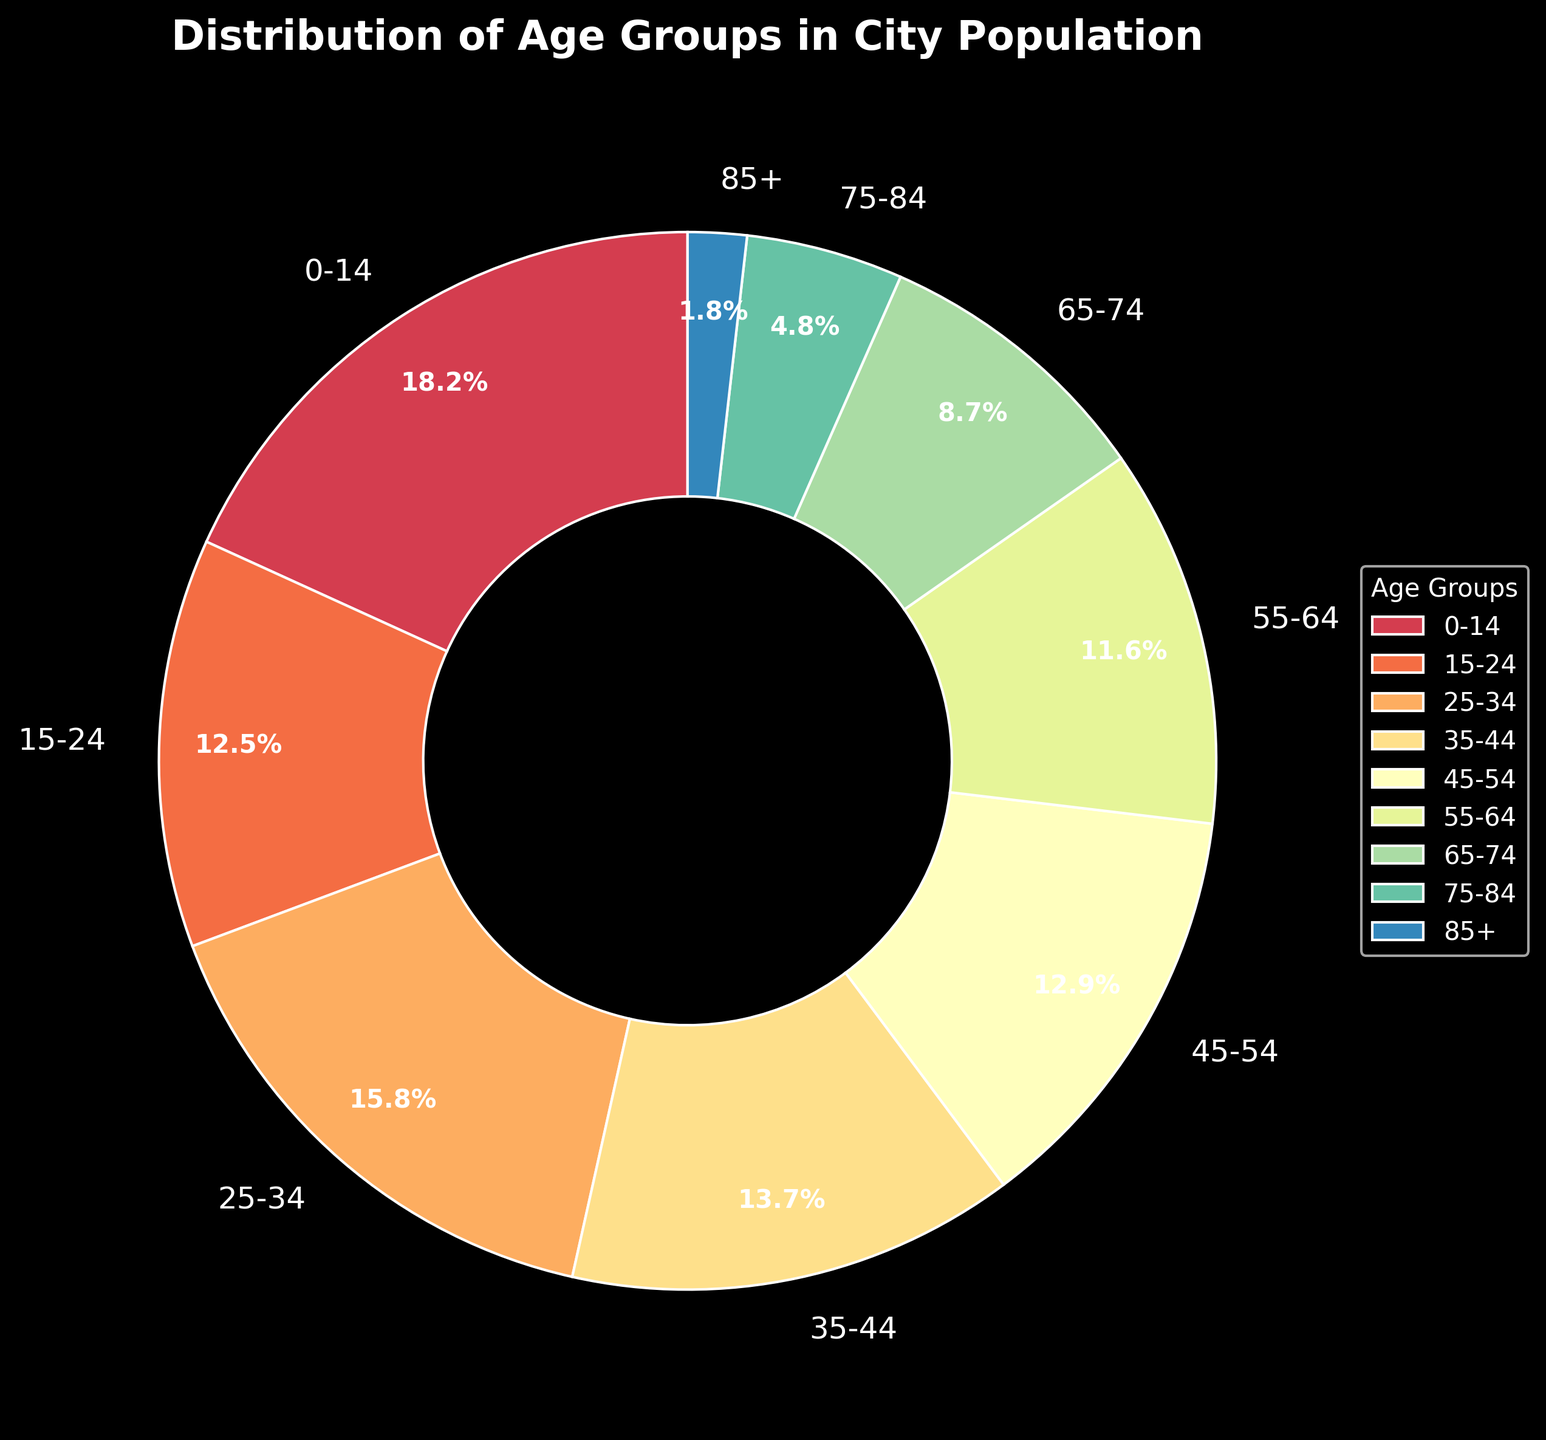Which age group has the highest population percentage? The pie chart shows that the '0-14' age group has the highest percentage.
Answer: 0-14 Which age group has the lowest population percentage? The '85+' age group has the smallest slice in the pie chart.
Answer: 85+ How much larger is the population percentage of the '25-34' age group compared to the '75-84' age group? The '25-34' age group has 15.8%, and the '75-84' age group has 4.8%. The difference is 15.8% - 4.8% = 11%.
Answer: 11% What is the total population percentage of the age groups 0-14, 15-24, and 25-34 combined? Add the percentages of the '0-14' (18.2%), '15-24' (12.5%), and '25-34' (15.8%) age groups: 18.2% + 12.5% + 15.8% = 46.5%.
Answer: 46.5% Does the '55-64' age group have a higher population percentage than the '65-74' age group? The '55-64' age group has a percentage of 11.6%, while the '65-74' age group has 8.7%. Since 11.6% is greater than 8.7%, '55-64' has a higher percentage.
Answer: Yes What is the difference between the population percentages of the '35-44' and '45-54' age groups? The '35-44' age group has 13.7%, and the '45-54' age group has 12.9%. The difference is 13.7% - 12.9% = 0.8%.
Answer: 0.8% What is the average population percentage for all age groups? Sum all the percentages and divide by the number of age groups: (18.2 + 12.5 + 15.8 + 13.7 + 12.9 + 11.6 + 8.7 + 4.8 + 1.8) / 9 = 11.1%.
Answer: 11.1% Which three age groups have the smallest population percentages, and what is their combined percentage? The smallest percentages are for the '85+' (1.8%), '75-84' (4.8%), and '65-74' (8.7%) age groups. Combined, their total is 1.8% + 4.8% + 8.7% = 15.3%.
Answer: 85+, 75-84, and 65-74; 15.3% Is the population percentage of the '35-44' age group closer to that of the '15-24' age group or the '45-54' age group? The percentage for '35-44' is 13.7%. The distances to '15-24' (12.5%) and '45-54' (12.9%) are 13.7% - 12.5% = 1.2% and 13.7% - 12.9% = 0.8%, respectively. Therefore, it is closer to '45-54'.
Answer: 45-54 